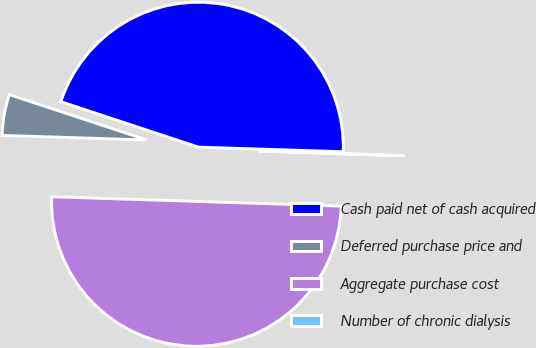Convert chart to OTSL. <chart><loc_0><loc_0><loc_500><loc_500><pie_chart><fcel>Cash paid net of cash acquired<fcel>Deferred purchase price and<fcel>Aggregate purchase cost<fcel>Number of chronic dialysis<nl><fcel>45.43%<fcel>4.57%<fcel>49.99%<fcel>0.01%<nl></chart> 